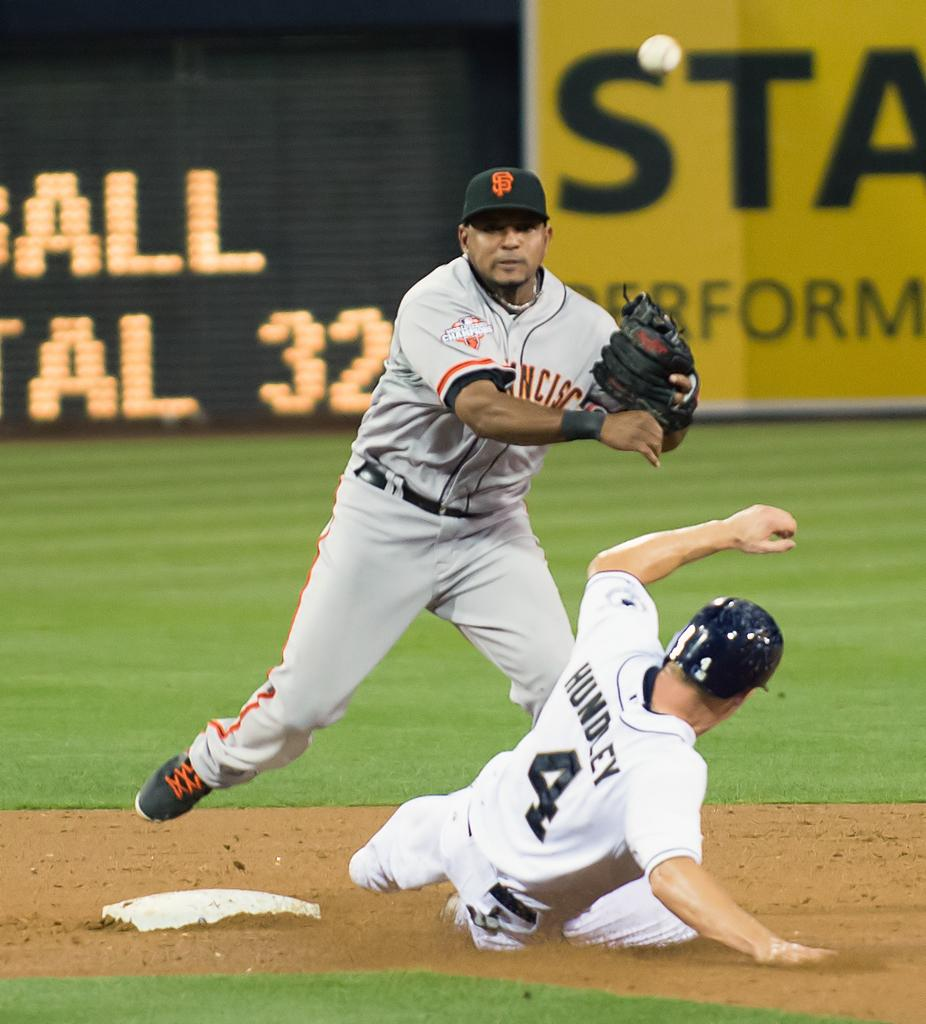Provide a one-sentence caption for the provided image. hundley #4 sliding into base as san francisco player waiting for ball. 